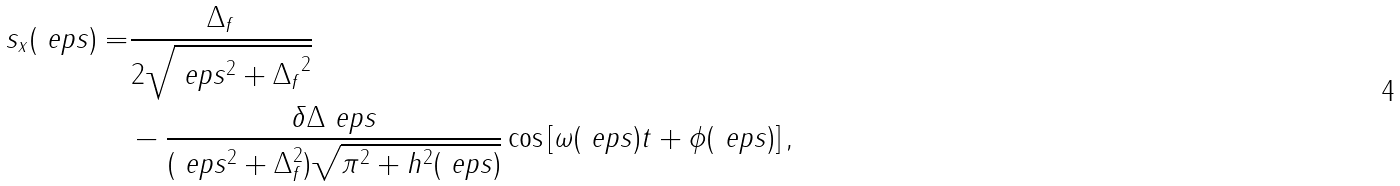Convert formula to latex. <formula><loc_0><loc_0><loc_500><loc_500>s _ { x } ( \ e p s ) = & \frac { \Delta _ { f } } { 2 \sqrt { \ e p s ^ { 2 } + { \Delta _ { f } } ^ { 2 } } } \\ & - \frac { \delta \Delta \ e p s } { ( \ e p s ^ { 2 } + \Delta _ { f } ^ { 2 } ) \sqrt { \pi ^ { 2 } + h ^ { 2 } ( \ e p s ) } } \cos \left [ \omega ( \ e p s ) t + \phi ( \ e p s ) \right ] ,</formula> 